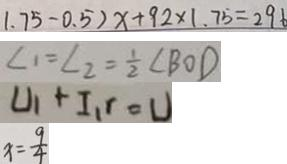Convert formula to latex. <formula><loc_0><loc_0><loc_500><loc_500>1 . 7 5 - 0 . 5 ) x + 9 2 \times 1 . 7 5 = 2 9 6 
 \angle 1 = \angle 2 = \frac { 1 } { 2 } \angle B O D 
 U _ { 1 } + I _ { 1 } r = U 
 x = \frac { 9 } { 4 }</formula> 